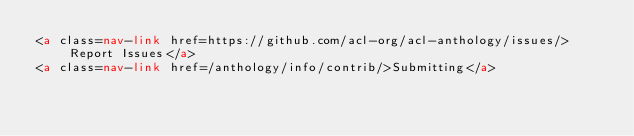Convert code to text. <code><loc_0><loc_0><loc_500><loc_500><_HTML_><a class=nav-link href=https://github.com/acl-org/acl-anthology/issues/>Report Issues</a>
<a class=nav-link href=/anthology/info/contrib/>Submitting</a></code> 